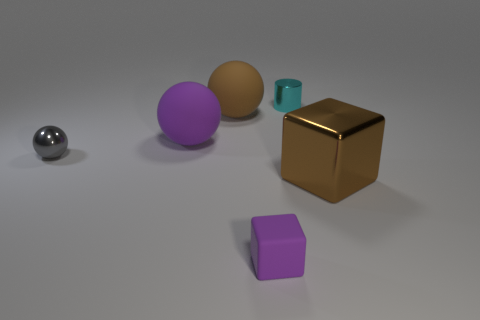Add 3 brown metal cubes. How many objects exist? 9 Subtract all blocks. How many objects are left? 4 Subtract all rubber blocks. Subtract all tiny matte blocks. How many objects are left? 4 Add 4 large rubber spheres. How many large rubber spheres are left? 6 Add 5 tiny gray metallic spheres. How many tiny gray metallic spheres exist? 6 Subtract 1 purple cubes. How many objects are left? 5 